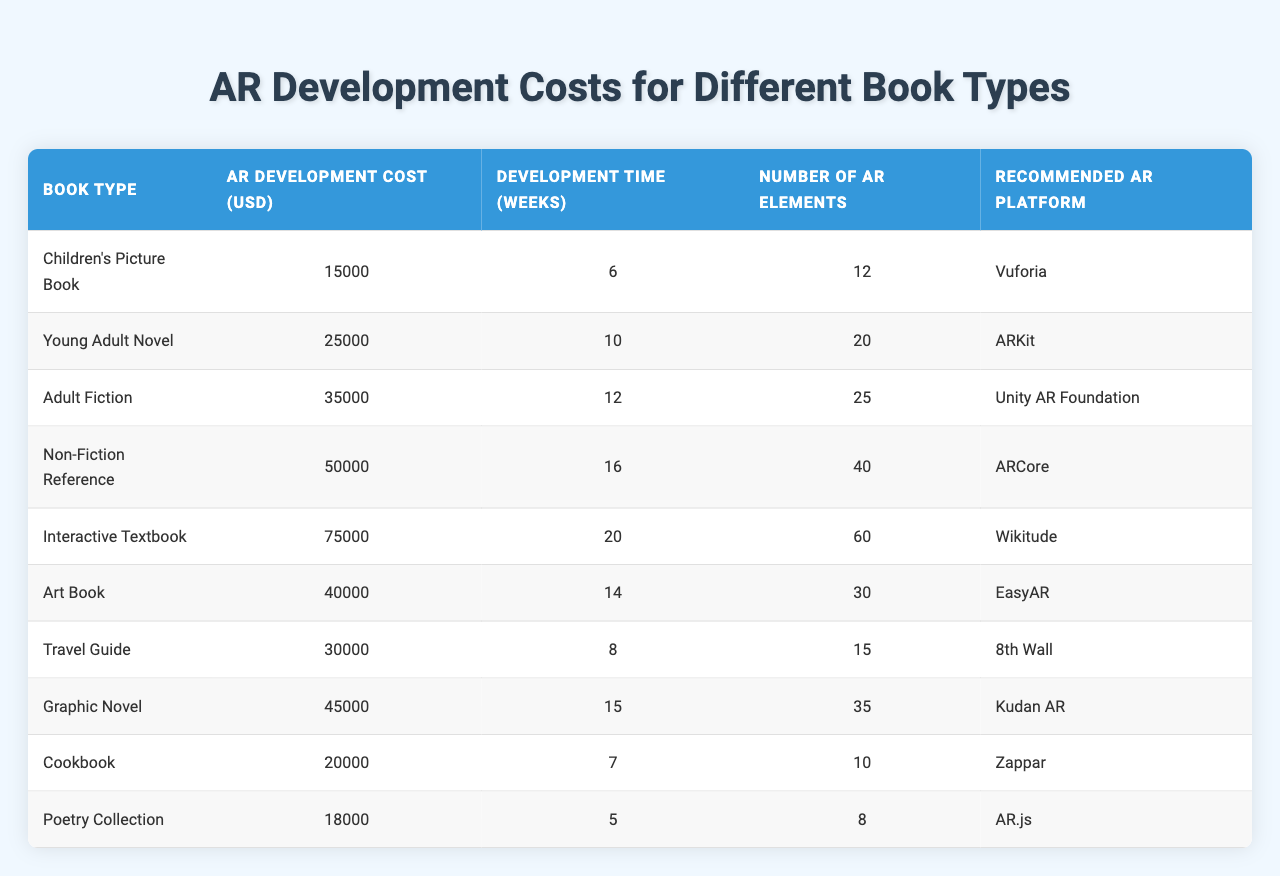What is the AR development cost for a Children's Picture Book? The table states that the AR development cost for a Children's Picture Book is 15,000 USD.
Answer: 15,000 USD Which AR platform is recommended for Interactive Textbooks? According to the table, the recommended AR platform for Interactive Textbooks is Wikitude.
Answer: Wikitude How many AR elements are included in an Adult Fiction? The table indicates that an Adult Fiction includes 25 AR elements.
Answer: 25 AR elements What is the total development time for both the Young Adult Novel and the Adult Fiction? The development time for a Young Adult Novel is 10 weeks and for an Adult Fiction is 12 weeks. Adding these gives 10 + 12 = 22 weeks.
Answer: 22 weeks Is the AR development cost for a Travel Guide less than that of a Cookbook? The table shows that the Travel Guide costs 30,000 USD and the Cookbook costs 20,000 USD. Since 30,000 is greater than 20,000, the statement is false.
Answer: No What is the average AR development cost across all book types listed? The AR development costs are 15,000, 25,000, 35,000, 50,000, 75,000, 40,000, 30,000, 45,000, 20,000, and 18,000 USD. Adding these gives a total of  15,000 + 25,000 + 35,000 + 50,000 + 75,000 + 40,000 + 30,000 + 45,000 + 20,000 + 18,000 =  413,000 USD. There are 10 book types, so the average is 413,000 / 10 = 41,300 USD.
Answer: 41,300 USD Which book type requires the longest development time and how many weeks does it take? The Interactive Textbook requires the longest development time at 20 weeks, as indicated in the table.
Answer: Interactive Textbook, 20 weeks How does the number of AR elements for a Graphic Novel compare to that of a Cookbook? For a Graphic Novel, the number of AR elements is 35, while for a Cookbook, it is 10. Comparing these, 35 is greater than 10.
Answer: Graphic Novel has more AR elements If you wanted to create an AR feature for both a Children's Picture Book and a Poetry Collection, what would be the total development cost? The development cost for a Children's Picture Book is 15,000 USD and for a Poetry Collection is 18,000 USD. Adding these gives 15,000 + 18,000 = 33,000 USD.
Answer: 33,000 USD What is the difference in the number of AR elements between an Adult Fiction and a Non-Fiction Reference book? An Adult Fiction has 25 AR elements, while a Non-Fiction Reference has 40 AR elements. The difference is 40 - 25 = 15 AR elements.
Answer: 15 AR elements What is the AR development cost for the most expensive book type listed? The most expensive book type is the Interactive Textbook, which has an AR development cost of 75,000 USD.
Answer: 75,000 USD 